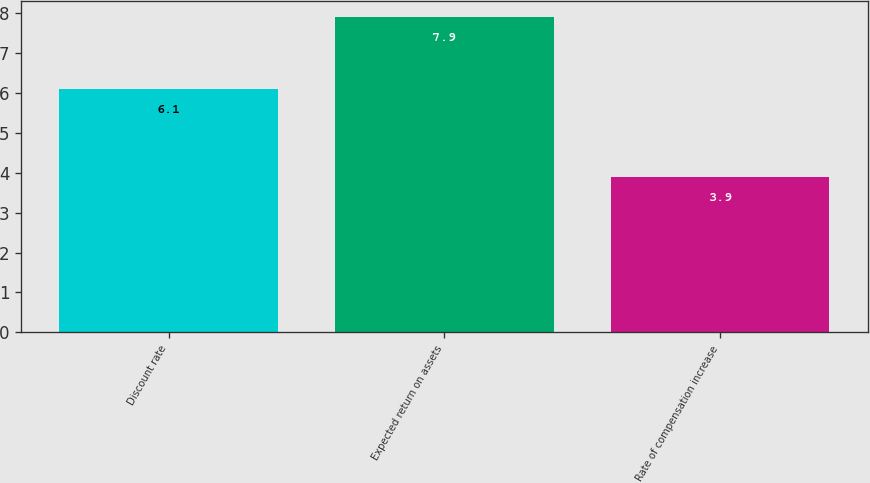Convert chart. <chart><loc_0><loc_0><loc_500><loc_500><bar_chart><fcel>Discount rate<fcel>Expected return on assets<fcel>Rate of compensation increase<nl><fcel>6.1<fcel>7.9<fcel>3.9<nl></chart> 